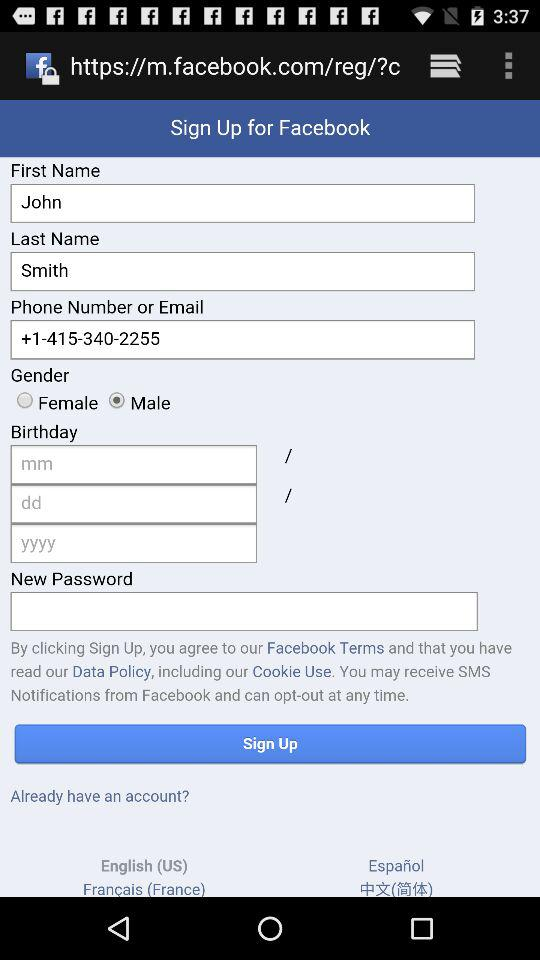What is the last name? The last name is Smith. 